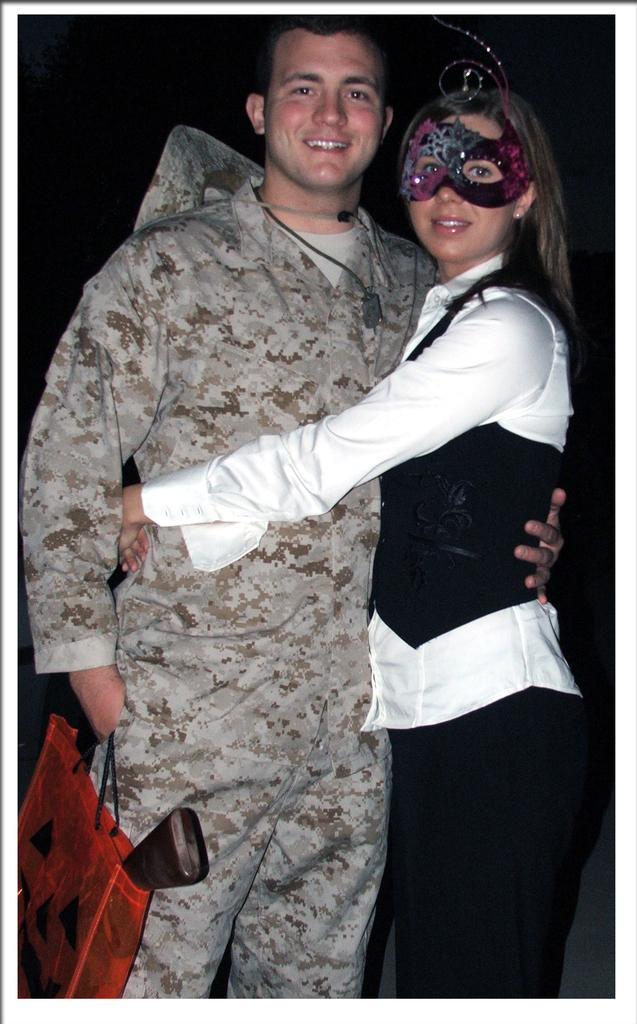How many people are in the image? There are two people in the image, a man and a woman. What is the man holding in the image? The man is holding a bag. What is the woman wearing in the image? The woman is wearing a mask. What can be said about the background of the image? The background of the image is dark. What type of basket is the maid carrying in the image? There is no maid or basket present in the image. What emotion is the man feeling in the image? The image does not provide any information about the man's emotions, so it cannot be determined from the image. 